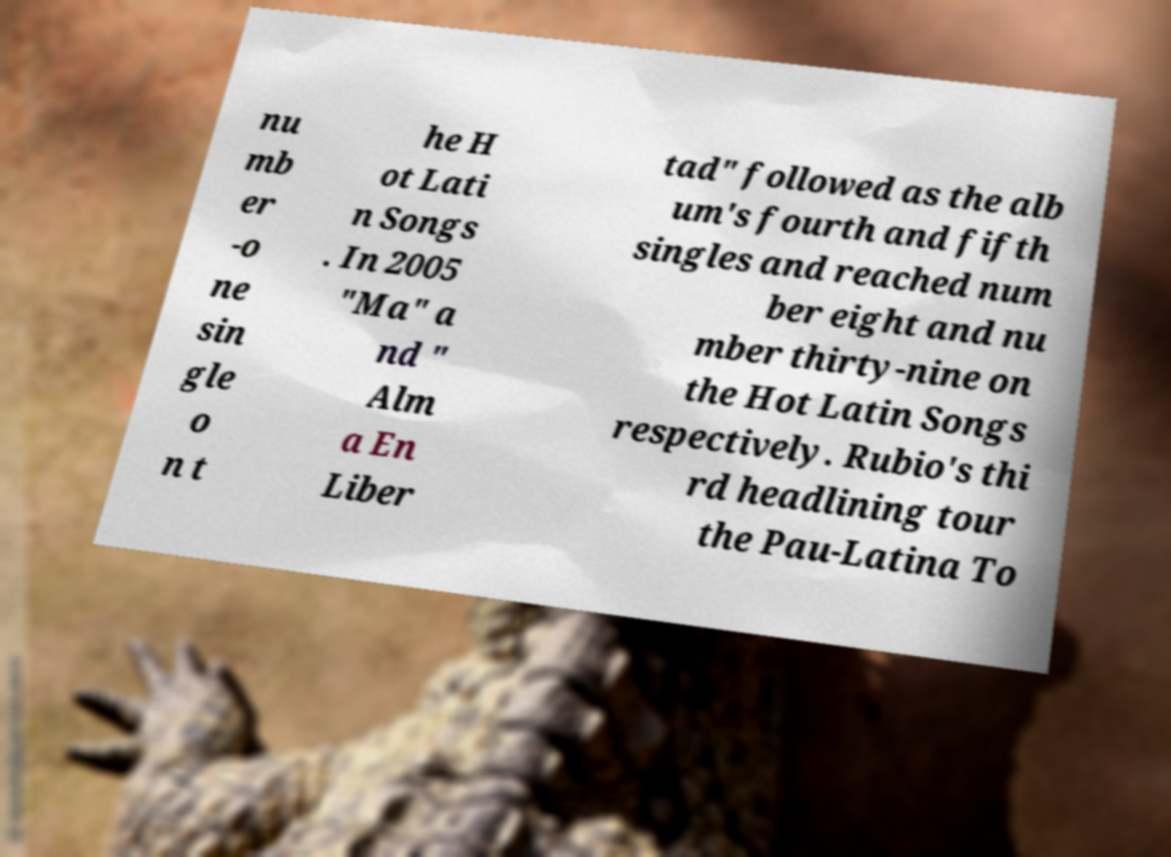There's text embedded in this image that I need extracted. Can you transcribe it verbatim? nu mb er -o ne sin gle o n t he H ot Lati n Songs . In 2005 "Ma" a nd " Alm a En Liber tad" followed as the alb um's fourth and fifth singles and reached num ber eight and nu mber thirty-nine on the Hot Latin Songs respectively. Rubio's thi rd headlining tour the Pau-Latina To 